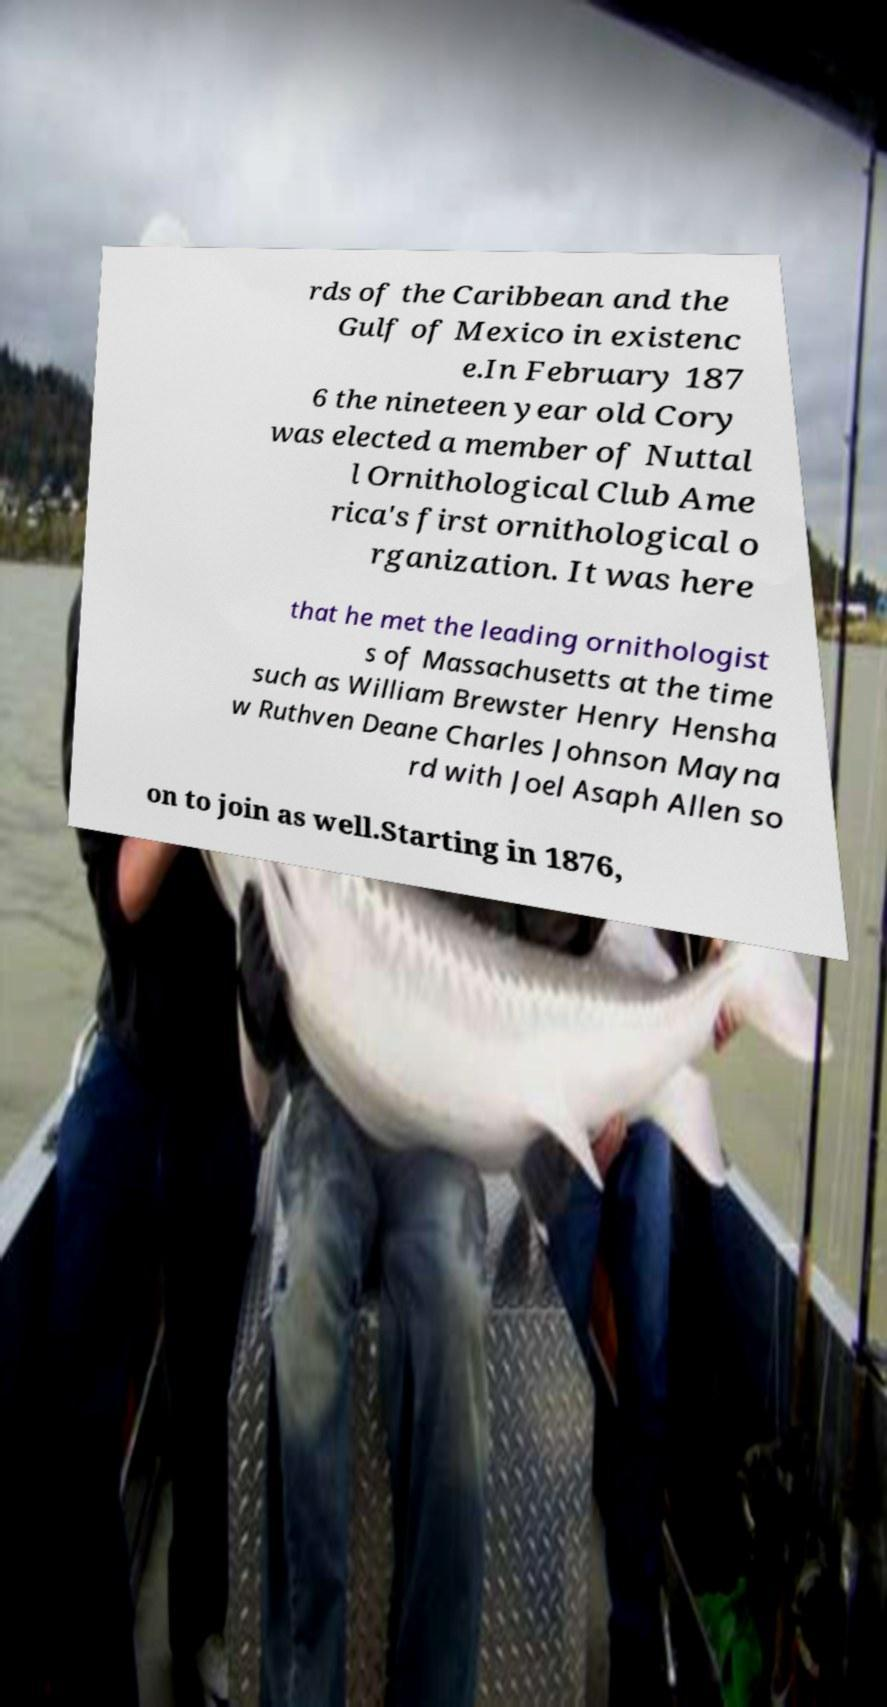Please read and relay the text visible in this image. What does it say? rds of the Caribbean and the Gulf of Mexico in existenc e.In February 187 6 the nineteen year old Cory was elected a member of Nuttal l Ornithological Club Ame rica's first ornithological o rganization. It was here that he met the leading ornithologist s of Massachusetts at the time such as William Brewster Henry Hensha w Ruthven Deane Charles Johnson Mayna rd with Joel Asaph Allen so on to join as well.Starting in 1876, 